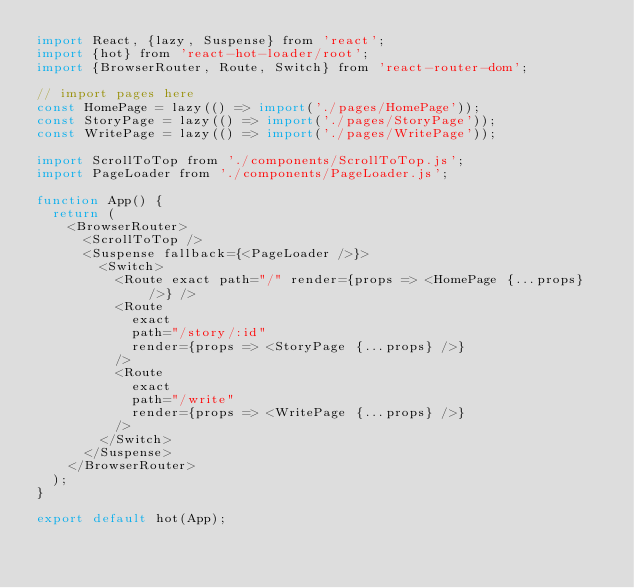Convert code to text. <code><loc_0><loc_0><loc_500><loc_500><_JavaScript_>import React, {lazy, Suspense} from 'react';
import {hot} from 'react-hot-loader/root';
import {BrowserRouter, Route, Switch} from 'react-router-dom';

// import pages here
const HomePage = lazy(() => import('./pages/HomePage'));
const StoryPage = lazy(() => import('./pages/StoryPage'));
const WritePage = lazy(() => import('./pages/WritePage'));

import ScrollToTop from './components/ScrollToTop.js';
import PageLoader from './components/PageLoader.js';

function App() {
  return (
    <BrowserRouter>
      <ScrollToTop />
      <Suspense fallback={<PageLoader />}>
        <Switch>
          <Route exact path="/" render={props => <HomePage {...props} />} />
          <Route
            exact
            path="/story/:id"
            render={props => <StoryPage {...props} />}
          />
          <Route
            exact
            path="/write"
            render={props => <WritePage {...props} />}
          />
        </Switch>
      </Suspense>
    </BrowserRouter>
  );
}

export default hot(App);
</code> 